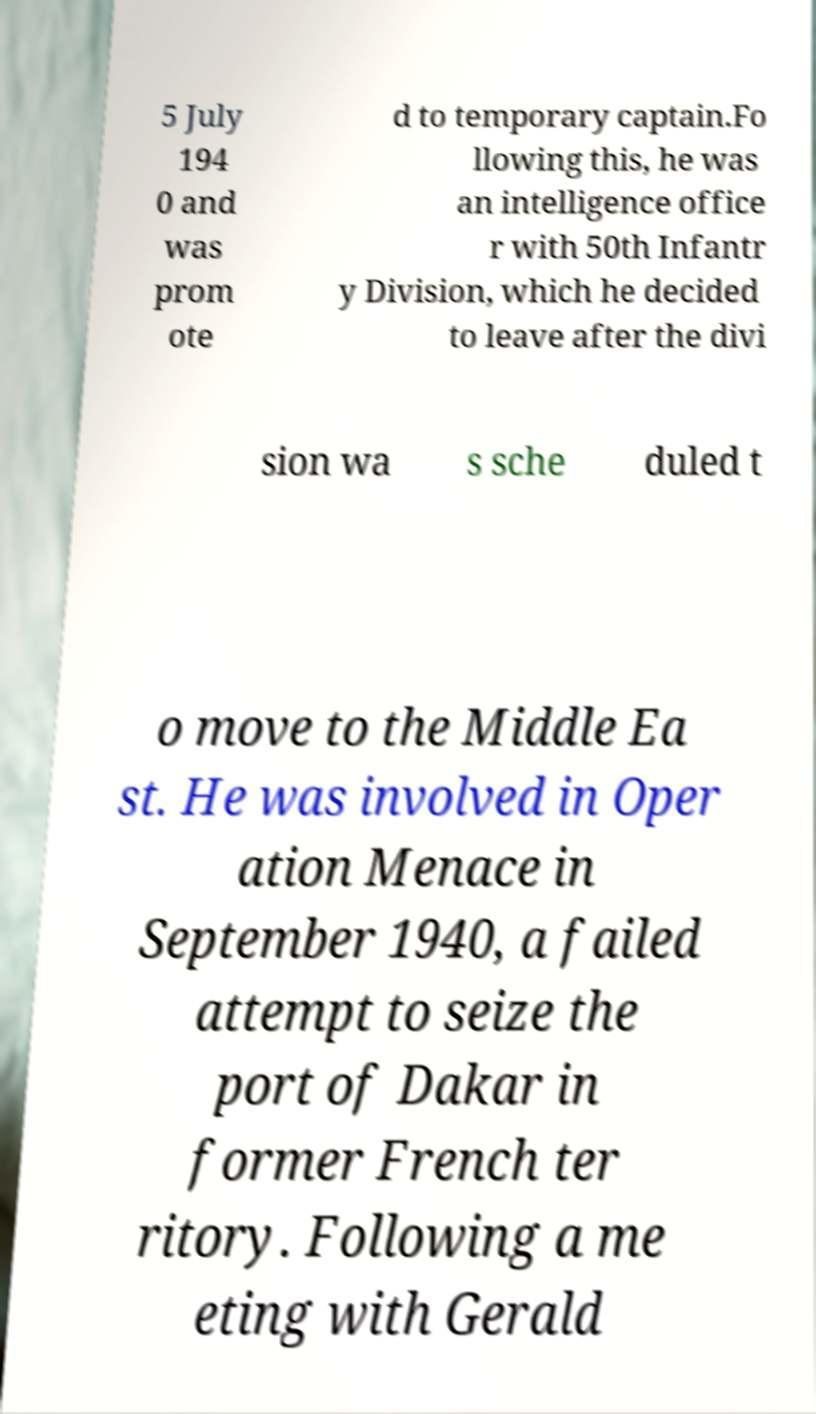Can you read and provide the text displayed in the image?This photo seems to have some interesting text. Can you extract and type it out for me? 5 July 194 0 and was prom ote d to temporary captain.Fo llowing this, he was an intelligence office r with 50th Infantr y Division, which he decided to leave after the divi sion wa s sche duled t o move to the Middle Ea st. He was involved in Oper ation Menace in September 1940, a failed attempt to seize the port of Dakar in former French ter ritory. Following a me eting with Gerald 